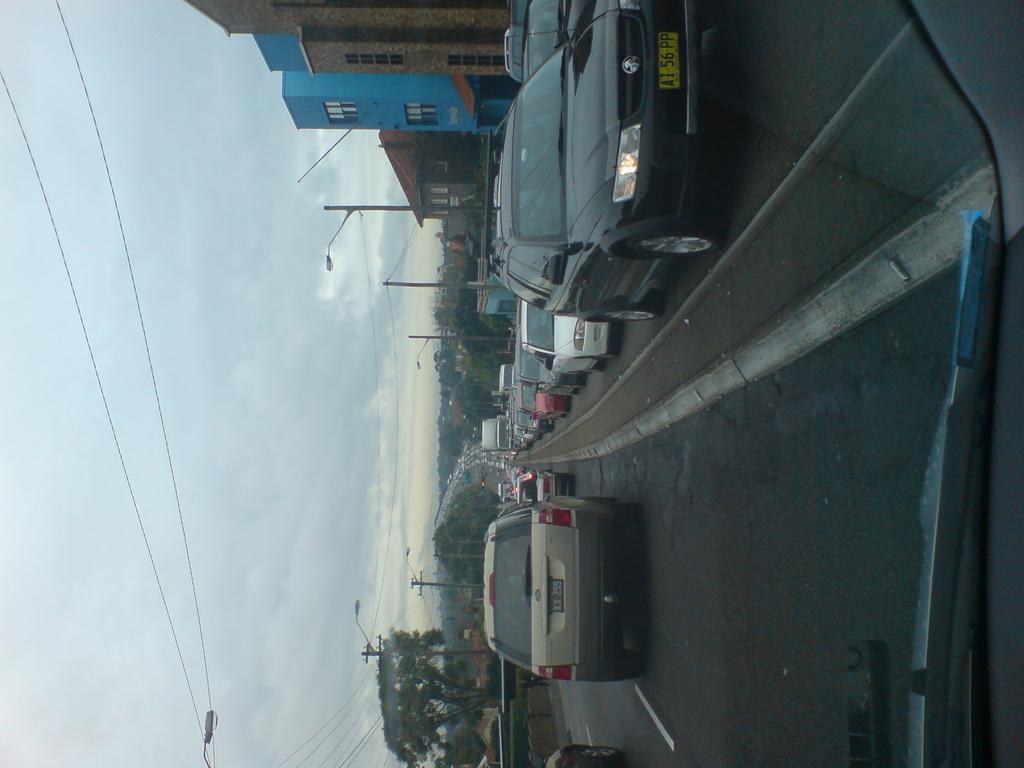Describe this image in one or two sentences. In this image I can see the road. On the road there are many vehicles. To the side of the road I can see many trees and the buildings. I can also see the current poles and the light poles. In the background there are clouds and the sky. 